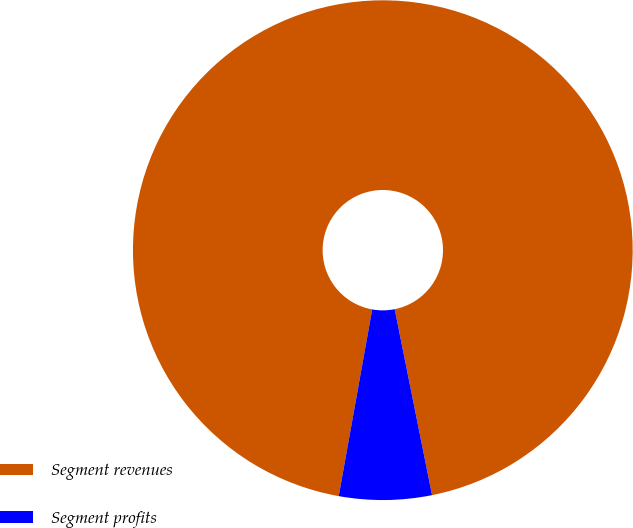Convert chart. <chart><loc_0><loc_0><loc_500><loc_500><pie_chart><fcel>Segment revenues<fcel>Segment profits<nl><fcel>94.02%<fcel>5.98%<nl></chart> 